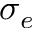Convert formula to latex. <formula><loc_0><loc_0><loc_500><loc_500>\sigma _ { e }</formula> 